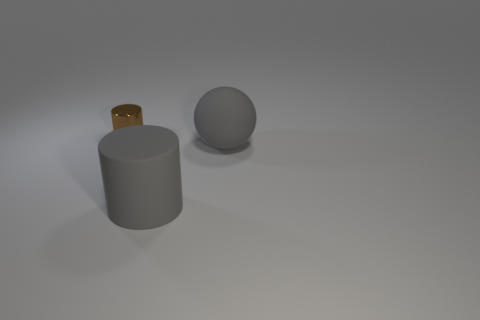Are there any other things that are made of the same material as the tiny cylinder?
Offer a terse response. No. Are the cylinder that is right of the metallic cylinder and the cylinder behind the large matte cylinder made of the same material?
Your response must be concise. No. What size is the rubber object that is the same shape as the shiny object?
Keep it short and to the point. Large. How many objects are things that are in front of the tiny cylinder or small cyan matte blocks?
Your answer should be very brief. 2. There is a gray thing that is the same material as the large sphere; what size is it?
Your answer should be compact. Large. How many metallic cylinders have the same color as the big rubber cylinder?
Your response must be concise. 0. What number of small objects are gray cylinders or metal cylinders?
Your answer should be very brief. 1. Are there any large gray objects that have the same material as the big gray sphere?
Offer a very short reply. Yes. There is a gray object in front of the big gray ball; what is it made of?
Your response must be concise. Rubber. Do the thing on the right side of the large gray cylinder and the cylinder that is left of the big gray cylinder have the same color?
Offer a terse response. No. 